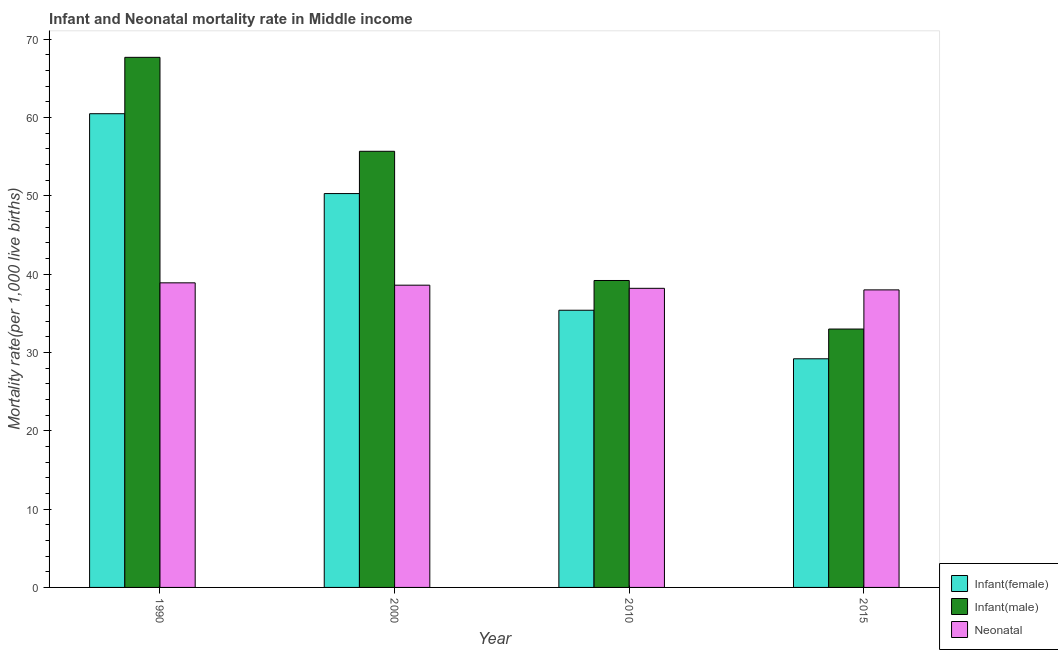How many different coloured bars are there?
Ensure brevity in your answer.  3. How many groups of bars are there?
Ensure brevity in your answer.  4. Are the number of bars per tick equal to the number of legend labels?
Offer a terse response. Yes. In how many cases, is the number of bars for a given year not equal to the number of legend labels?
Provide a succinct answer. 0. What is the neonatal mortality rate in 1990?
Provide a short and direct response. 38.9. Across all years, what is the maximum infant mortality rate(female)?
Keep it short and to the point. 60.5. Across all years, what is the minimum infant mortality rate(female)?
Ensure brevity in your answer.  29.2. In which year was the neonatal mortality rate maximum?
Your answer should be compact. 1990. In which year was the neonatal mortality rate minimum?
Make the answer very short. 2015. What is the total neonatal mortality rate in the graph?
Give a very brief answer. 153.7. What is the difference between the infant mortality rate(female) in 1990 and that in 2010?
Make the answer very short. 25.1. What is the difference between the infant mortality rate(female) in 2010 and the infant mortality rate(male) in 2015?
Give a very brief answer. 6.2. What is the average neonatal mortality rate per year?
Ensure brevity in your answer.  38.42. What is the ratio of the neonatal mortality rate in 1990 to that in 2000?
Ensure brevity in your answer.  1.01. Is the infant mortality rate(male) in 1990 less than that in 2015?
Make the answer very short. No. What is the difference between the highest and the lowest neonatal mortality rate?
Provide a succinct answer. 0.9. In how many years, is the infant mortality rate(male) greater than the average infant mortality rate(male) taken over all years?
Your answer should be compact. 2. What does the 3rd bar from the left in 2000 represents?
Keep it short and to the point. Neonatal . What does the 3rd bar from the right in 2015 represents?
Keep it short and to the point. Infant(female). Is it the case that in every year, the sum of the infant mortality rate(female) and infant mortality rate(male) is greater than the neonatal mortality rate?
Offer a terse response. Yes. How many bars are there?
Offer a very short reply. 12. Are all the bars in the graph horizontal?
Provide a short and direct response. No. Are the values on the major ticks of Y-axis written in scientific E-notation?
Ensure brevity in your answer.  No. How many legend labels are there?
Provide a short and direct response. 3. How are the legend labels stacked?
Give a very brief answer. Vertical. What is the title of the graph?
Your answer should be very brief. Infant and Neonatal mortality rate in Middle income. What is the label or title of the Y-axis?
Provide a succinct answer. Mortality rate(per 1,0 live births). What is the Mortality rate(per 1,000 live births) of Infant(female) in 1990?
Give a very brief answer. 60.5. What is the Mortality rate(per 1,000 live births) in Infant(male) in 1990?
Your response must be concise. 67.7. What is the Mortality rate(per 1,000 live births) of Neonatal  in 1990?
Give a very brief answer. 38.9. What is the Mortality rate(per 1,000 live births) in Infant(female) in 2000?
Offer a very short reply. 50.3. What is the Mortality rate(per 1,000 live births) in Infant(male) in 2000?
Your answer should be very brief. 55.7. What is the Mortality rate(per 1,000 live births) of Neonatal  in 2000?
Offer a terse response. 38.6. What is the Mortality rate(per 1,000 live births) in Infant(female) in 2010?
Your answer should be very brief. 35.4. What is the Mortality rate(per 1,000 live births) of Infant(male) in 2010?
Offer a very short reply. 39.2. What is the Mortality rate(per 1,000 live births) in Neonatal  in 2010?
Your answer should be very brief. 38.2. What is the Mortality rate(per 1,000 live births) in Infant(female) in 2015?
Offer a terse response. 29.2. What is the Mortality rate(per 1,000 live births) of Infant(male) in 2015?
Give a very brief answer. 33. What is the Mortality rate(per 1,000 live births) of Neonatal  in 2015?
Offer a terse response. 38. Across all years, what is the maximum Mortality rate(per 1,000 live births) of Infant(female)?
Give a very brief answer. 60.5. Across all years, what is the maximum Mortality rate(per 1,000 live births) in Infant(male)?
Give a very brief answer. 67.7. Across all years, what is the maximum Mortality rate(per 1,000 live births) of Neonatal ?
Make the answer very short. 38.9. Across all years, what is the minimum Mortality rate(per 1,000 live births) in Infant(female)?
Your answer should be very brief. 29.2. Across all years, what is the minimum Mortality rate(per 1,000 live births) of Infant(male)?
Your response must be concise. 33. What is the total Mortality rate(per 1,000 live births) of Infant(female) in the graph?
Make the answer very short. 175.4. What is the total Mortality rate(per 1,000 live births) of Infant(male) in the graph?
Your response must be concise. 195.6. What is the total Mortality rate(per 1,000 live births) in Neonatal  in the graph?
Your response must be concise. 153.7. What is the difference between the Mortality rate(per 1,000 live births) in Infant(female) in 1990 and that in 2000?
Your response must be concise. 10.2. What is the difference between the Mortality rate(per 1,000 live births) of Infant(male) in 1990 and that in 2000?
Provide a short and direct response. 12. What is the difference between the Mortality rate(per 1,000 live births) of Neonatal  in 1990 and that in 2000?
Your answer should be very brief. 0.3. What is the difference between the Mortality rate(per 1,000 live births) in Infant(female) in 1990 and that in 2010?
Make the answer very short. 25.1. What is the difference between the Mortality rate(per 1,000 live births) in Infant(male) in 1990 and that in 2010?
Provide a short and direct response. 28.5. What is the difference between the Mortality rate(per 1,000 live births) of Infant(female) in 1990 and that in 2015?
Your response must be concise. 31.3. What is the difference between the Mortality rate(per 1,000 live births) of Infant(male) in 1990 and that in 2015?
Keep it short and to the point. 34.7. What is the difference between the Mortality rate(per 1,000 live births) of Neonatal  in 1990 and that in 2015?
Give a very brief answer. 0.9. What is the difference between the Mortality rate(per 1,000 live births) in Infant(female) in 2000 and that in 2010?
Make the answer very short. 14.9. What is the difference between the Mortality rate(per 1,000 live births) in Infant(male) in 2000 and that in 2010?
Your answer should be very brief. 16.5. What is the difference between the Mortality rate(per 1,000 live births) in Infant(female) in 2000 and that in 2015?
Make the answer very short. 21.1. What is the difference between the Mortality rate(per 1,000 live births) in Infant(male) in 2000 and that in 2015?
Make the answer very short. 22.7. What is the difference between the Mortality rate(per 1,000 live births) of Neonatal  in 2000 and that in 2015?
Provide a short and direct response. 0.6. What is the difference between the Mortality rate(per 1,000 live births) in Infant(male) in 2010 and that in 2015?
Give a very brief answer. 6.2. What is the difference between the Mortality rate(per 1,000 live births) of Neonatal  in 2010 and that in 2015?
Ensure brevity in your answer.  0.2. What is the difference between the Mortality rate(per 1,000 live births) in Infant(female) in 1990 and the Mortality rate(per 1,000 live births) in Infant(male) in 2000?
Offer a very short reply. 4.8. What is the difference between the Mortality rate(per 1,000 live births) in Infant(female) in 1990 and the Mortality rate(per 1,000 live births) in Neonatal  in 2000?
Make the answer very short. 21.9. What is the difference between the Mortality rate(per 1,000 live births) of Infant(male) in 1990 and the Mortality rate(per 1,000 live births) of Neonatal  in 2000?
Your answer should be compact. 29.1. What is the difference between the Mortality rate(per 1,000 live births) in Infant(female) in 1990 and the Mortality rate(per 1,000 live births) in Infant(male) in 2010?
Your response must be concise. 21.3. What is the difference between the Mortality rate(per 1,000 live births) in Infant(female) in 1990 and the Mortality rate(per 1,000 live births) in Neonatal  in 2010?
Keep it short and to the point. 22.3. What is the difference between the Mortality rate(per 1,000 live births) of Infant(male) in 1990 and the Mortality rate(per 1,000 live births) of Neonatal  in 2010?
Ensure brevity in your answer.  29.5. What is the difference between the Mortality rate(per 1,000 live births) in Infant(male) in 1990 and the Mortality rate(per 1,000 live births) in Neonatal  in 2015?
Your answer should be compact. 29.7. What is the difference between the Mortality rate(per 1,000 live births) in Infant(female) in 2000 and the Mortality rate(per 1,000 live births) in Infant(male) in 2010?
Offer a terse response. 11.1. What is the difference between the Mortality rate(per 1,000 live births) of Infant(female) in 2000 and the Mortality rate(per 1,000 live births) of Neonatal  in 2010?
Make the answer very short. 12.1. What is the difference between the Mortality rate(per 1,000 live births) in Infant(male) in 2000 and the Mortality rate(per 1,000 live births) in Neonatal  in 2010?
Your answer should be compact. 17.5. What is the difference between the Mortality rate(per 1,000 live births) of Infant(female) in 2000 and the Mortality rate(per 1,000 live births) of Infant(male) in 2015?
Your answer should be very brief. 17.3. What is the difference between the Mortality rate(per 1,000 live births) in Infant(female) in 2010 and the Mortality rate(per 1,000 live births) in Infant(male) in 2015?
Your response must be concise. 2.4. What is the difference between the Mortality rate(per 1,000 live births) of Infant(female) in 2010 and the Mortality rate(per 1,000 live births) of Neonatal  in 2015?
Keep it short and to the point. -2.6. What is the difference between the Mortality rate(per 1,000 live births) of Infant(male) in 2010 and the Mortality rate(per 1,000 live births) of Neonatal  in 2015?
Make the answer very short. 1.2. What is the average Mortality rate(per 1,000 live births) in Infant(female) per year?
Keep it short and to the point. 43.85. What is the average Mortality rate(per 1,000 live births) in Infant(male) per year?
Give a very brief answer. 48.9. What is the average Mortality rate(per 1,000 live births) of Neonatal  per year?
Offer a very short reply. 38.42. In the year 1990, what is the difference between the Mortality rate(per 1,000 live births) of Infant(female) and Mortality rate(per 1,000 live births) of Infant(male)?
Provide a short and direct response. -7.2. In the year 1990, what is the difference between the Mortality rate(per 1,000 live births) of Infant(female) and Mortality rate(per 1,000 live births) of Neonatal ?
Offer a terse response. 21.6. In the year 1990, what is the difference between the Mortality rate(per 1,000 live births) of Infant(male) and Mortality rate(per 1,000 live births) of Neonatal ?
Offer a very short reply. 28.8. In the year 2000, what is the difference between the Mortality rate(per 1,000 live births) of Infant(female) and Mortality rate(per 1,000 live births) of Neonatal ?
Provide a short and direct response. 11.7. In the year 2000, what is the difference between the Mortality rate(per 1,000 live births) in Infant(male) and Mortality rate(per 1,000 live births) in Neonatal ?
Ensure brevity in your answer.  17.1. In the year 2015, what is the difference between the Mortality rate(per 1,000 live births) in Infant(female) and Mortality rate(per 1,000 live births) in Infant(male)?
Give a very brief answer. -3.8. In the year 2015, what is the difference between the Mortality rate(per 1,000 live births) in Infant(female) and Mortality rate(per 1,000 live births) in Neonatal ?
Your response must be concise. -8.8. What is the ratio of the Mortality rate(per 1,000 live births) in Infant(female) in 1990 to that in 2000?
Give a very brief answer. 1.2. What is the ratio of the Mortality rate(per 1,000 live births) of Infant(male) in 1990 to that in 2000?
Keep it short and to the point. 1.22. What is the ratio of the Mortality rate(per 1,000 live births) of Neonatal  in 1990 to that in 2000?
Keep it short and to the point. 1.01. What is the ratio of the Mortality rate(per 1,000 live births) of Infant(female) in 1990 to that in 2010?
Make the answer very short. 1.71. What is the ratio of the Mortality rate(per 1,000 live births) of Infant(male) in 1990 to that in 2010?
Keep it short and to the point. 1.73. What is the ratio of the Mortality rate(per 1,000 live births) of Neonatal  in 1990 to that in 2010?
Offer a terse response. 1.02. What is the ratio of the Mortality rate(per 1,000 live births) of Infant(female) in 1990 to that in 2015?
Provide a succinct answer. 2.07. What is the ratio of the Mortality rate(per 1,000 live births) in Infant(male) in 1990 to that in 2015?
Give a very brief answer. 2.05. What is the ratio of the Mortality rate(per 1,000 live births) in Neonatal  in 1990 to that in 2015?
Your answer should be very brief. 1.02. What is the ratio of the Mortality rate(per 1,000 live births) of Infant(female) in 2000 to that in 2010?
Your response must be concise. 1.42. What is the ratio of the Mortality rate(per 1,000 live births) of Infant(male) in 2000 to that in 2010?
Give a very brief answer. 1.42. What is the ratio of the Mortality rate(per 1,000 live births) in Neonatal  in 2000 to that in 2010?
Your answer should be compact. 1.01. What is the ratio of the Mortality rate(per 1,000 live births) of Infant(female) in 2000 to that in 2015?
Provide a succinct answer. 1.72. What is the ratio of the Mortality rate(per 1,000 live births) in Infant(male) in 2000 to that in 2015?
Give a very brief answer. 1.69. What is the ratio of the Mortality rate(per 1,000 live births) of Neonatal  in 2000 to that in 2015?
Offer a terse response. 1.02. What is the ratio of the Mortality rate(per 1,000 live births) of Infant(female) in 2010 to that in 2015?
Offer a very short reply. 1.21. What is the ratio of the Mortality rate(per 1,000 live births) in Infant(male) in 2010 to that in 2015?
Ensure brevity in your answer.  1.19. What is the ratio of the Mortality rate(per 1,000 live births) in Neonatal  in 2010 to that in 2015?
Offer a very short reply. 1.01. What is the difference between the highest and the second highest Mortality rate(per 1,000 live births) in Infant(female)?
Provide a succinct answer. 10.2. What is the difference between the highest and the lowest Mortality rate(per 1,000 live births) of Infant(female)?
Offer a very short reply. 31.3. What is the difference between the highest and the lowest Mortality rate(per 1,000 live births) of Infant(male)?
Keep it short and to the point. 34.7. 